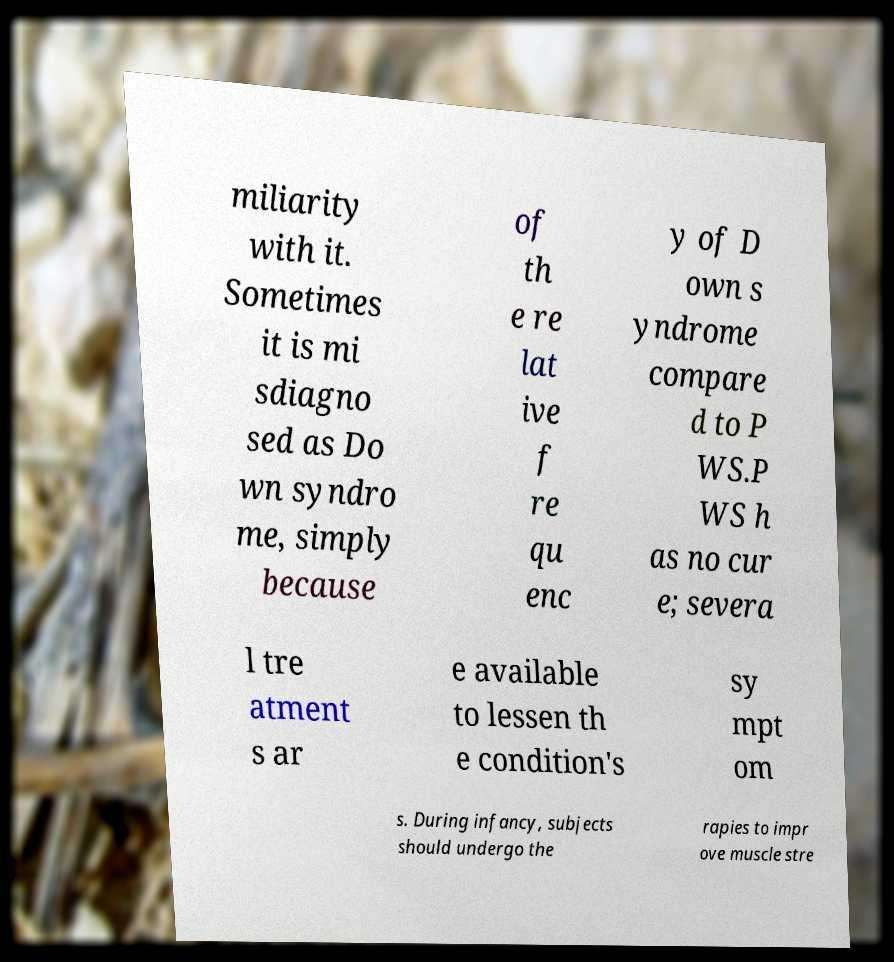For documentation purposes, I need the text within this image transcribed. Could you provide that? miliarity with it. Sometimes it is mi sdiagno sed as Do wn syndro me, simply because of th e re lat ive f re qu enc y of D own s yndrome compare d to P WS.P WS h as no cur e; severa l tre atment s ar e available to lessen th e condition's sy mpt om s. During infancy, subjects should undergo the rapies to impr ove muscle stre 